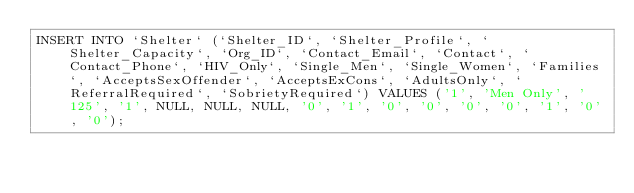<code> <loc_0><loc_0><loc_500><loc_500><_SQL_>INSERT INTO `Shelter` (`Shelter_ID`, `Shelter_Profile`, `Shelter_Capacity`, `Org_ID`, `Contact_Email`, `Contact`, `Contact_Phone`, `HIV_Only`, `Single_Men`, `Single_Women`, `Families`, `AcceptsSexOffender`, `AcceptsExCons`, `AdultsOnly`, `ReferralRequired`, `SobrietyRequired`) VALUES ('1', 'Men Only', '125', '1', NULL, NULL, NULL, '0', '1', '0', '0', '0', '0', '1', '0', '0');</code> 